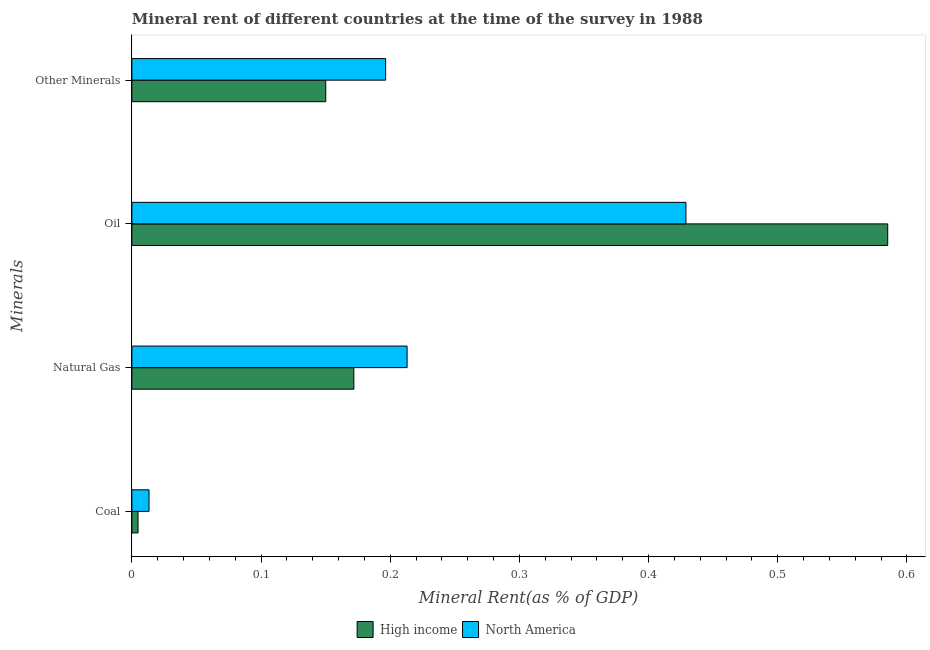How many groups of bars are there?
Your answer should be compact. 4. Are the number of bars on each tick of the Y-axis equal?
Offer a very short reply. Yes. How many bars are there on the 1st tick from the bottom?
Ensure brevity in your answer.  2. What is the label of the 3rd group of bars from the top?
Ensure brevity in your answer.  Natural Gas. What is the  rent of other minerals in North America?
Ensure brevity in your answer.  0.2. Across all countries, what is the maximum coal rent?
Your answer should be very brief. 0.01. Across all countries, what is the minimum  rent of other minerals?
Offer a very short reply. 0.15. In which country was the natural gas rent maximum?
Your answer should be very brief. North America. In which country was the  rent of other minerals minimum?
Ensure brevity in your answer.  High income. What is the total  rent of other minerals in the graph?
Keep it short and to the point. 0.35. What is the difference between the  rent of other minerals in North America and that in High income?
Your answer should be very brief. 0.05. What is the difference between the coal rent in North America and the natural gas rent in High income?
Ensure brevity in your answer.  -0.16. What is the average oil rent per country?
Your answer should be very brief. 0.51. What is the difference between the  rent of other minerals and natural gas rent in High income?
Your response must be concise. -0.02. In how many countries, is the natural gas rent greater than 0.12000000000000001 %?
Your answer should be compact. 2. What is the ratio of the coal rent in North America to that in High income?
Offer a terse response. 2.78. Is the  rent of other minerals in North America less than that in High income?
Provide a short and direct response. No. What is the difference between the highest and the second highest natural gas rent?
Your answer should be very brief. 0.04. What is the difference between the highest and the lowest oil rent?
Provide a succinct answer. 0.16. What does the 2nd bar from the bottom in Coal represents?
Your answer should be very brief. North America. Does the graph contain any zero values?
Your answer should be very brief. No. Does the graph contain grids?
Your answer should be very brief. No. How many legend labels are there?
Make the answer very short. 2. What is the title of the graph?
Offer a very short reply. Mineral rent of different countries at the time of the survey in 1988. Does "Afghanistan" appear as one of the legend labels in the graph?
Ensure brevity in your answer.  No. What is the label or title of the X-axis?
Your answer should be very brief. Mineral Rent(as % of GDP). What is the label or title of the Y-axis?
Offer a very short reply. Minerals. What is the Mineral Rent(as % of GDP) of High income in Coal?
Provide a short and direct response. 0. What is the Mineral Rent(as % of GDP) in North America in Coal?
Your answer should be compact. 0.01. What is the Mineral Rent(as % of GDP) in High income in Natural Gas?
Provide a short and direct response. 0.17. What is the Mineral Rent(as % of GDP) of North America in Natural Gas?
Make the answer very short. 0.21. What is the Mineral Rent(as % of GDP) of High income in Oil?
Provide a succinct answer. 0.59. What is the Mineral Rent(as % of GDP) in North America in Oil?
Provide a short and direct response. 0.43. What is the Mineral Rent(as % of GDP) of High income in Other Minerals?
Keep it short and to the point. 0.15. What is the Mineral Rent(as % of GDP) of North America in Other Minerals?
Provide a short and direct response. 0.2. Across all Minerals, what is the maximum Mineral Rent(as % of GDP) of High income?
Your answer should be very brief. 0.59. Across all Minerals, what is the maximum Mineral Rent(as % of GDP) of North America?
Provide a succinct answer. 0.43. Across all Minerals, what is the minimum Mineral Rent(as % of GDP) of High income?
Provide a succinct answer. 0. Across all Minerals, what is the minimum Mineral Rent(as % of GDP) in North America?
Provide a short and direct response. 0.01. What is the total Mineral Rent(as % of GDP) in High income in the graph?
Your answer should be compact. 0.91. What is the total Mineral Rent(as % of GDP) of North America in the graph?
Provide a short and direct response. 0.85. What is the difference between the Mineral Rent(as % of GDP) in High income in Coal and that in Natural Gas?
Provide a succinct answer. -0.17. What is the difference between the Mineral Rent(as % of GDP) in North America in Coal and that in Natural Gas?
Offer a terse response. -0.2. What is the difference between the Mineral Rent(as % of GDP) in High income in Coal and that in Oil?
Give a very brief answer. -0.58. What is the difference between the Mineral Rent(as % of GDP) of North America in Coal and that in Oil?
Your answer should be very brief. -0.42. What is the difference between the Mineral Rent(as % of GDP) of High income in Coal and that in Other Minerals?
Your response must be concise. -0.15. What is the difference between the Mineral Rent(as % of GDP) in North America in Coal and that in Other Minerals?
Provide a succinct answer. -0.18. What is the difference between the Mineral Rent(as % of GDP) in High income in Natural Gas and that in Oil?
Your answer should be compact. -0.41. What is the difference between the Mineral Rent(as % of GDP) of North America in Natural Gas and that in Oil?
Offer a very short reply. -0.22. What is the difference between the Mineral Rent(as % of GDP) of High income in Natural Gas and that in Other Minerals?
Your answer should be compact. 0.02. What is the difference between the Mineral Rent(as % of GDP) of North America in Natural Gas and that in Other Minerals?
Your response must be concise. 0.02. What is the difference between the Mineral Rent(as % of GDP) in High income in Oil and that in Other Minerals?
Your answer should be compact. 0.43. What is the difference between the Mineral Rent(as % of GDP) of North America in Oil and that in Other Minerals?
Provide a succinct answer. 0.23. What is the difference between the Mineral Rent(as % of GDP) of High income in Coal and the Mineral Rent(as % of GDP) of North America in Natural Gas?
Your response must be concise. -0.21. What is the difference between the Mineral Rent(as % of GDP) in High income in Coal and the Mineral Rent(as % of GDP) in North America in Oil?
Ensure brevity in your answer.  -0.42. What is the difference between the Mineral Rent(as % of GDP) in High income in Coal and the Mineral Rent(as % of GDP) in North America in Other Minerals?
Make the answer very short. -0.19. What is the difference between the Mineral Rent(as % of GDP) of High income in Natural Gas and the Mineral Rent(as % of GDP) of North America in Oil?
Offer a terse response. -0.26. What is the difference between the Mineral Rent(as % of GDP) of High income in Natural Gas and the Mineral Rent(as % of GDP) of North America in Other Minerals?
Ensure brevity in your answer.  -0.02. What is the difference between the Mineral Rent(as % of GDP) in High income in Oil and the Mineral Rent(as % of GDP) in North America in Other Minerals?
Ensure brevity in your answer.  0.39. What is the average Mineral Rent(as % of GDP) in High income per Minerals?
Your answer should be compact. 0.23. What is the average Mineral Rent(as % of GDP) of North America per Minerals?
Make the answer very short. 0.21. What is the difference between the Mineral Rent(as % of GDP) in High income and Mineral Rent(as % of GDP) in North America in Coal?
Keep it short and to the point. -0.01. What is the difference between the Mineral Rent(as % of GDP) of High income and Mineral Rent(as % of GDP) of North America in Natural Gas?
Offer a very short reply. -0.04. What is the difference between the Mineral Rent(as % of GDP) of High income and Mineral Rent(as % of GDP) of North America in Oil?
Provide a short and direct response. 0.16. What is the difference between the Mineral Rent(as % of GDP) of High income and Mineral Rent(as % of GDP) of North America in Other Minerals?
Your answer should be very brief. -0.05. What is the ratio of the Mineral Rent(as % of GDP) in High income in Coal to that in Natural Gas?
Ensure brevity in your answer.  0.03. What is the ratio of the Mineral Rent(as % of GDP) of North America in Coal to that in Natural Gas?
Offer a very short reply. 0.06. What is the ratio of the Mineral Rent(as % of GDP) in High income in Coal to that in Oil?
Offer a terse response. 0.01. What is the ratio of the Mineral Rent(as % of GDP) in North America in Coal to that in Oil?
Give a very brief answer. 0.03. What is the ratio of the Mineral Rent(as % of GDP) in High income in Coal to that in Other Minerals?
Keep it short and to the point. 0.03. What is the ratio of the Mineral Rent(as % of GDP) of North America in Coal to that in Other Minerals?
Offer a very short reply. 0.07. What is the ratio of the Mineral Rent(as % of GDP) in High income in Natural Gas to that in Oil?
Make the answer very short. 0.29. What is the ratio of the Mineral Rent(as % of GDP) in North America in Natural Gas to that in Oil?
Provide a short and direct response. 0.5. What is the ratio of the Mineral Rent(as % of GDP) of High income in Natural Gas to that in Other Minerals?
Give a very brief answer. 1.14. What is the ratio of the Mineral Rent(as % of GDP) in North America in Natural Gas to that in Other Minerals?
Ensure brevity in your answer.  1.08. What is the ratio of the Mineral Rent(as % of GDP) of High income in Oil to that in Other Minerals?
Your answer should be compact. 3.9. What is the ratio of the Mineral Rent(as % of GDP) of North America in Oil to that in Other Minerals?
Offer a very short reply. 2.18. What is the difference between the highest and the second highest Mineral Rent(as % of GDP) of High income?
Provide a short and direct response. 0.41. What is the difference between the highest and the second highest Mineral Rent(as % of GDP) in North America?
Keep it short and to the point. 0.22. What is the difference between the highest and the lowest Mineral Rent(as % of GDP) in High income?
Offer a terse response. 0.58. What is the difference between the highest and the lowest Mineral Rent(as % of GDP) in North America?
Give a very brief answer. 0.42. 